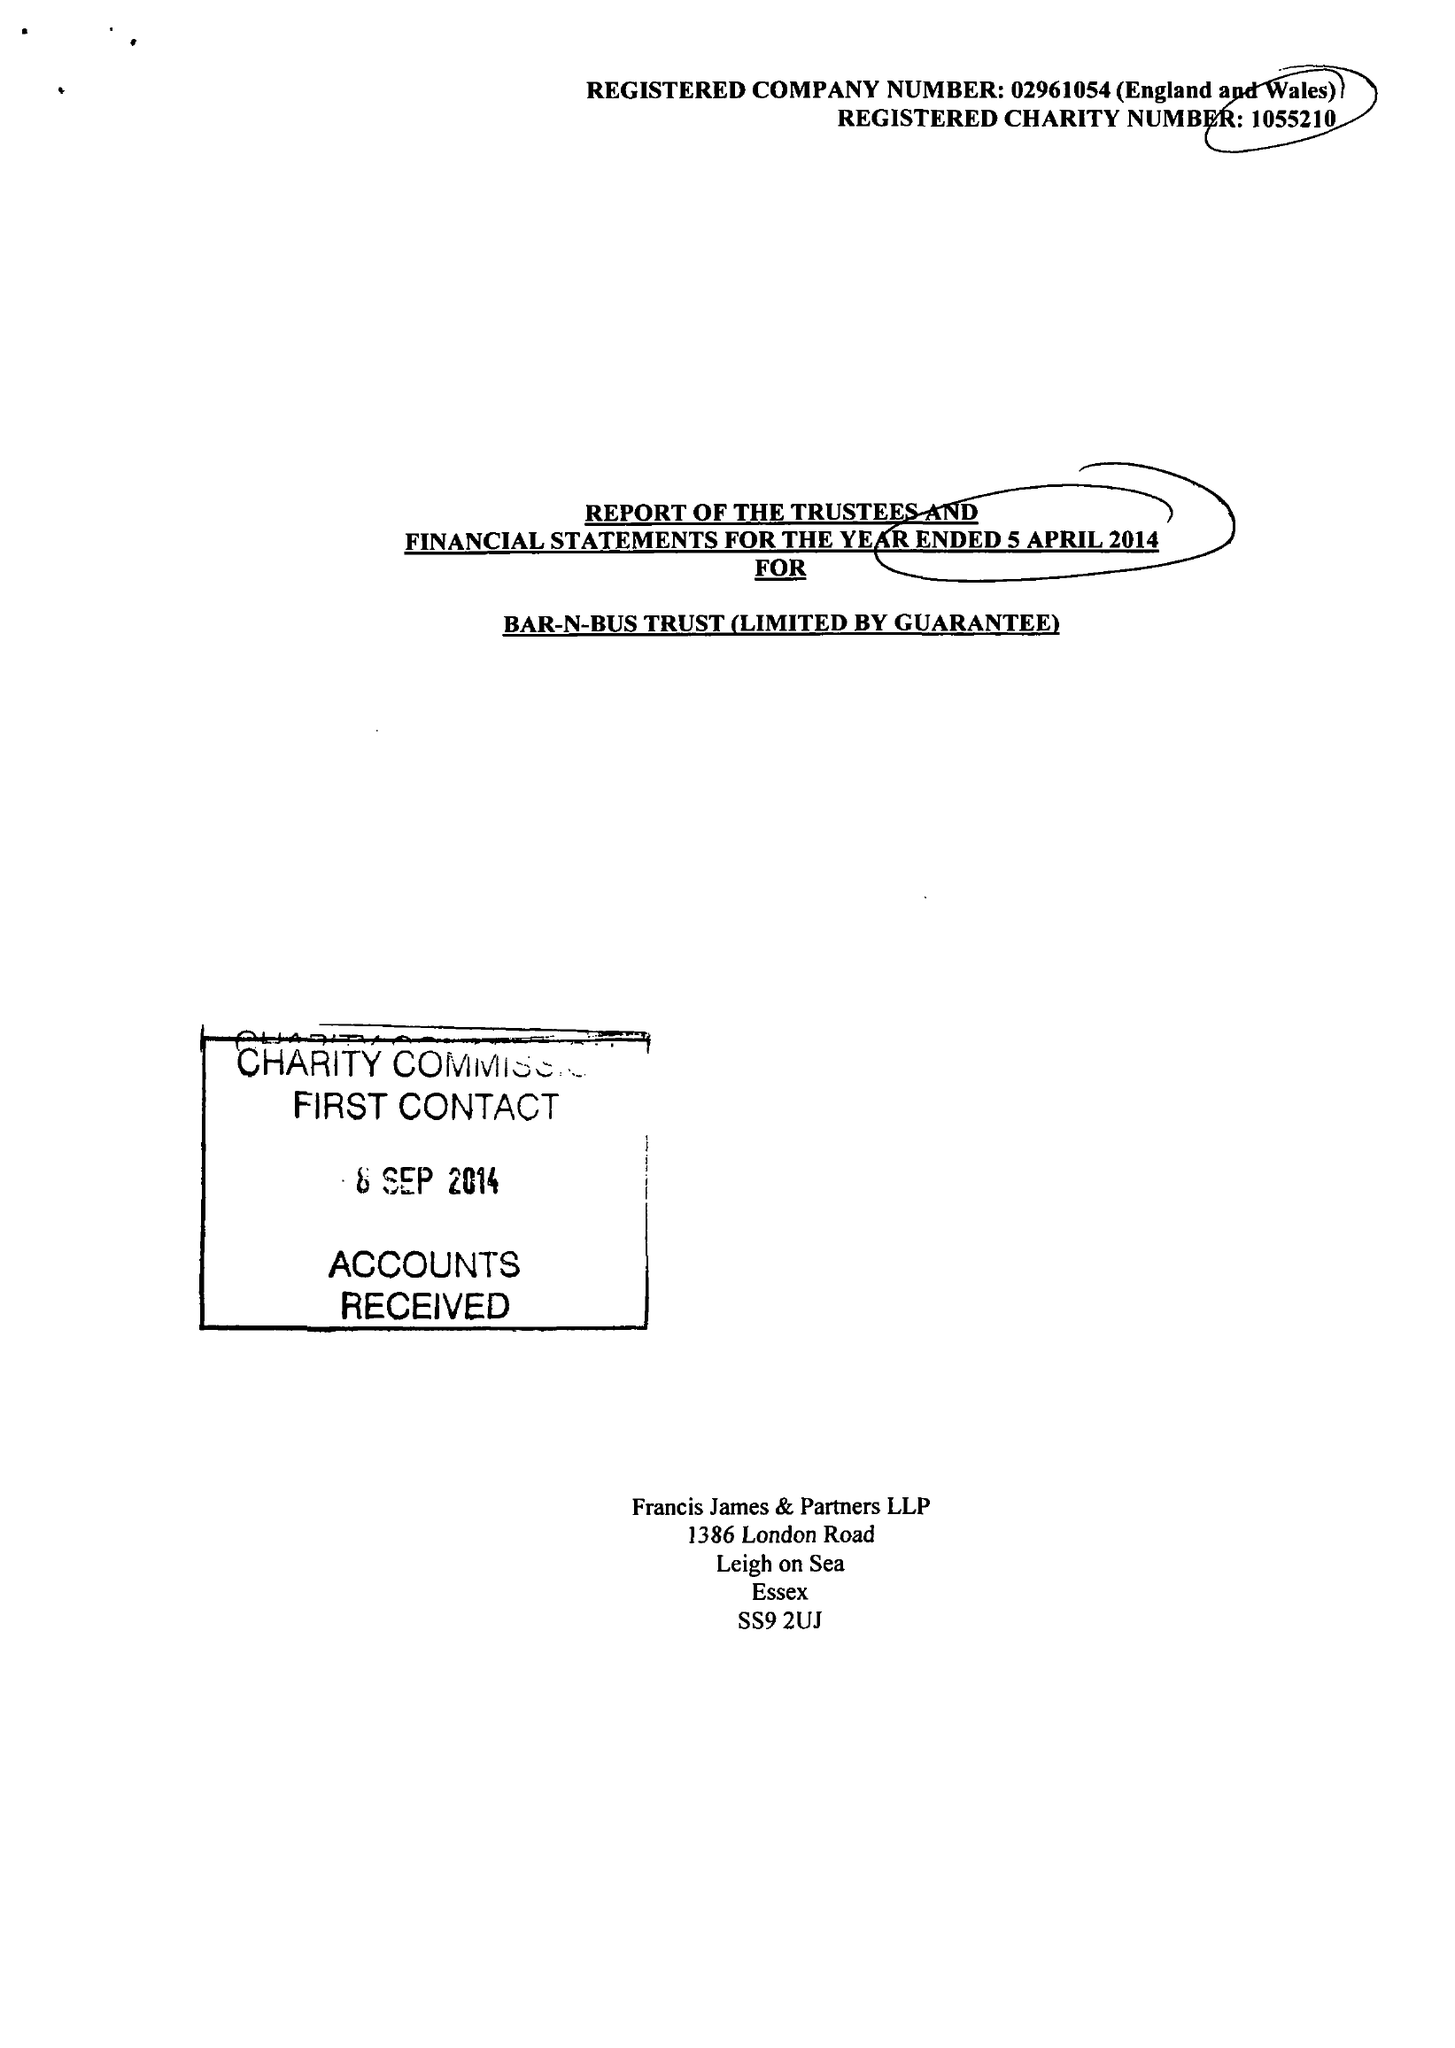What is the value for the income_annually_in_british_pounds?
Answer the question using a single word or phrase. 91266.00 